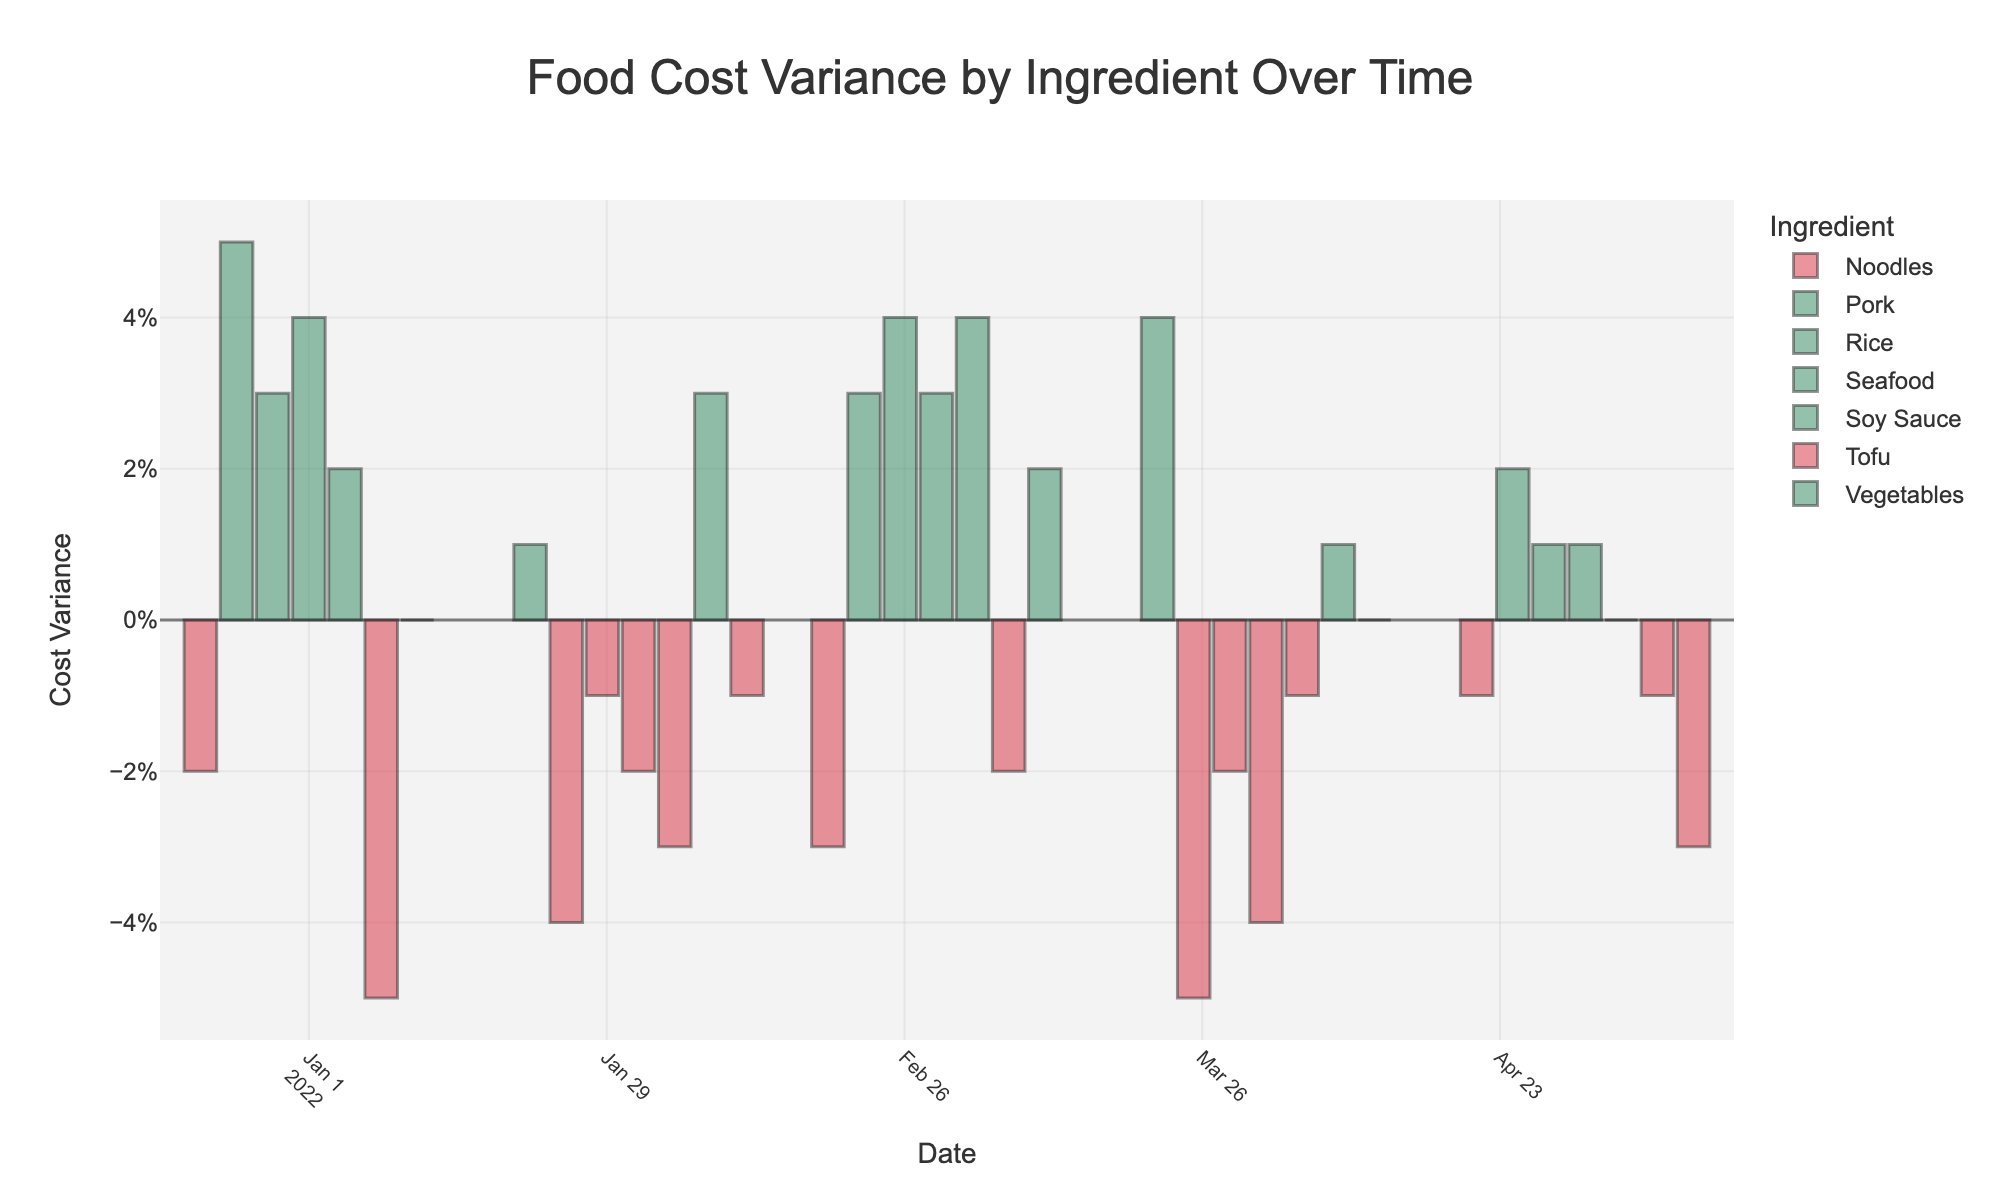What is the cost variance for Rice in March 2022? Look at the March 2022 bar for Rice and read the height of the bar along the y-axis. It is at 0.04.
Answer: 0.04 Which ingredient had the highest cost variance in January 2022? Compare the heights of the bars for each ingredient in January 2022, noting the highest bar. Pork has the highest bar at 0.05.
Answer: Pork Which ingredient consistently experienced negative cost variance every other month? Check all the months for each ingredient and see which one has alternating bars below the x-axis. Tofu had negative variances in January, March, and May.
Answer: Tofu How many times did the cost variance for Pork go below zero? Look through the bars for Pork and count how many times the bars dip below the x-axis. Pork had negative variances in February and April.
Answer: 2 Comparing cost variances in April 2022, which ingredient had the highest positive variance? Compare the heights of the bars in April 2022 and identify the ingredient with the highest positive value. Noodles have the highest positive variance at 0.04.
Answer: Noodles Which ingredient had a cost variance of zero in any given month, and what month was it? Look for a bar that aligns perfectly with the x-axis at zero and identify the corresponding ingredient and month. Vegetables had a cost variance of zero in January and April.
Answer: Vegetables in January and April What is the average cost variance for Rice from January to May 2022? Sum the variances for Rice (-0.01 + 0.03 + 0.04 - 0.02 + 0.01 = 0.05) and then divide by the number of months (5).
Answer: 0.01 